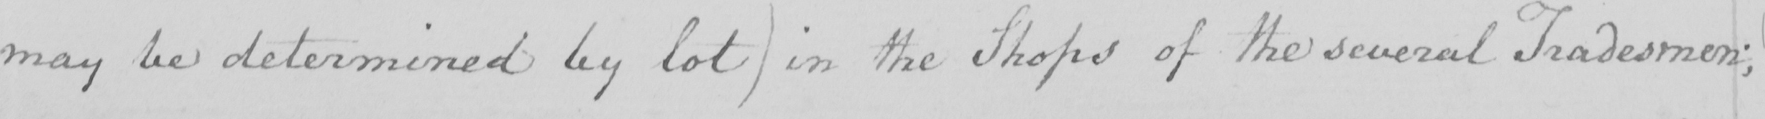Transcribe the text shown in this historical manuscript line. may be determined by lot) in the Shops of the several Tradesmen; 